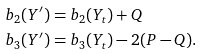Convert formula to latex. <formula><loc_0><loc_0><loc_500><loc_500>b _ { 2 } ( Y ^ { \prime } ) & = b _ { 2 } ( Y _ { t } ) + Q \\ b _ { 3 } ( Y ^ { \prime } ) & = b _ { 3 } ( Y _ { t } ) - 2 ( P - Q ) .</formula> 